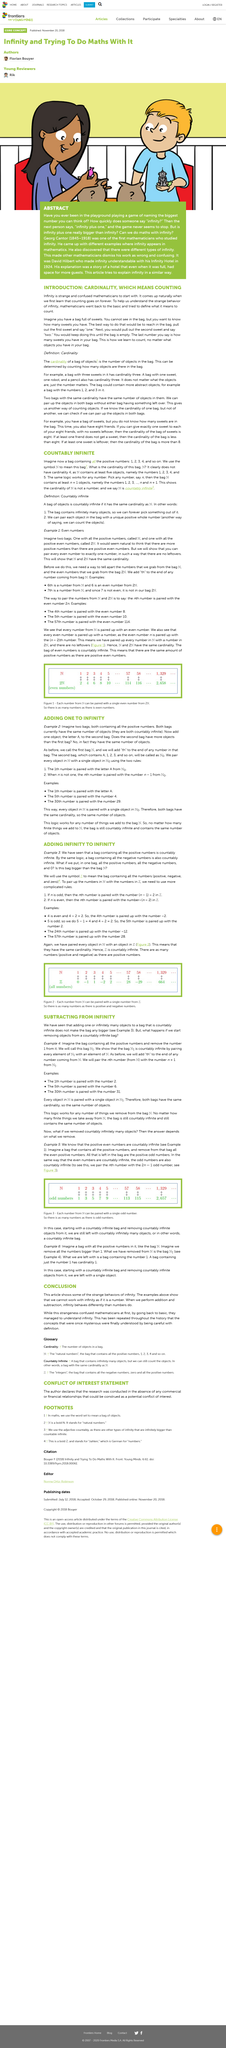Point out several critical features in this image. Infinity's behavior during addition and subtraction confuses mathematicians, as it does not follow the same rules as numbers. The two bags contain only positive numbers. Yes, there are an equal number of positive and negative numbers. What will the first bag be called? It will be called N.. The two bags are countably infinite. 